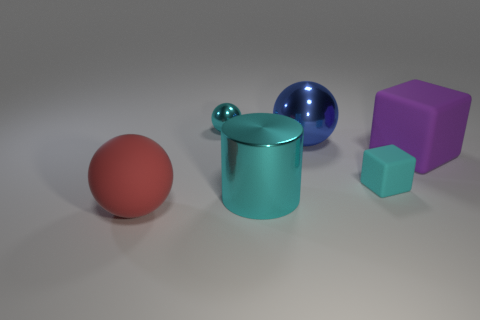What number of objects are the same color as the small sphere?
Make the answer very short. 2. There is a object that is on the left side of the big cyan cylinder and behind the small cyan block; how big is it?
Offer a very short reply. Small. Is the number of cyan balls that are behind the small ball less than the number of rubber blocks?
Give a very brief answer. Yes. Are the big cylinder and the large red ball made of the same material?
Keep it short and to the point. No. How many things are large metal things or big red metallic things?
Give a very brief answer. 2. What number of large purple cubes are the same material as the tiny cyan cube?
Give a very brief answer. 1. There is another thing that is the same shape as the cyan rubber thing; what size is it?
Give a very brief answer. Large. Are there any small cubes in front of the cyan cube?
Offer a very short reply. No. What is the big blue thing made of?
Offer a very short reply. Metal. Does the metallic object that is in front of the purple block have the same color as the small matte block?
Keep it short and to the point. Yes. 